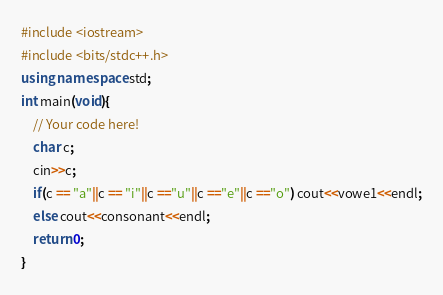<code> <loc_0><loc_0><loc_500><loc_500><_C++_>#include <iostream>
#include <bits/stdc++.h>
using namespace std;
int main(void){
    // Your code here!
    char c;
    cin>>c;
    if(c == "a"||c == "i"||c =="u"||c =="e"||c =="o") cout<<vowe1<<endl;
    else cout<<consonant<<endl;
    return 0;
}
</code> 